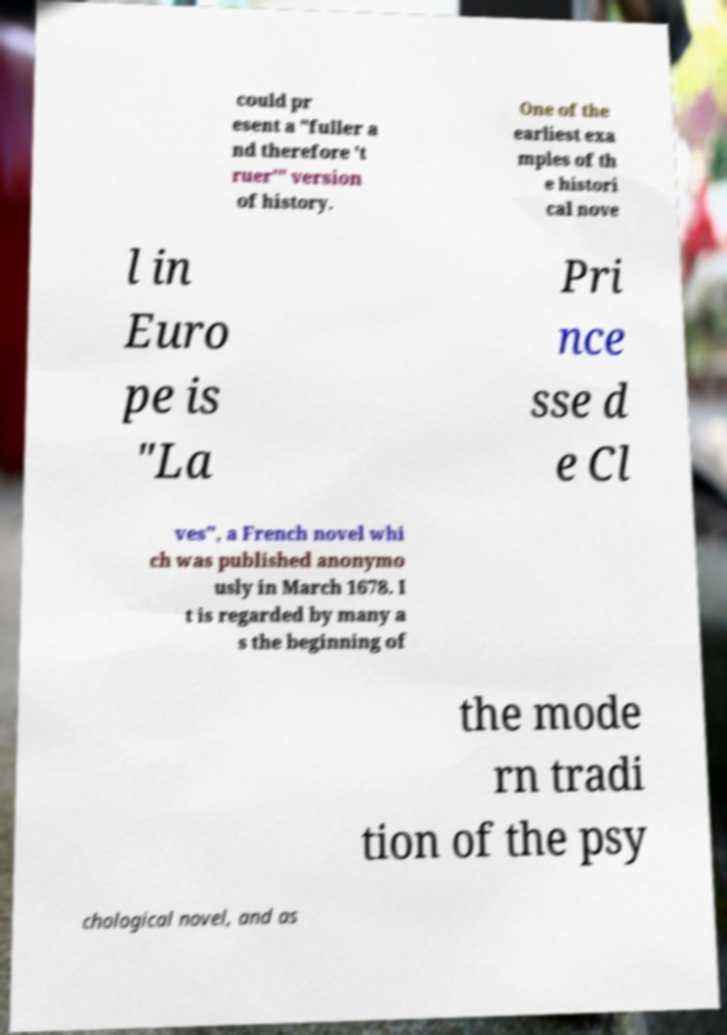I need the written content from this picture converted into text. Can you do that? could pr esent a "fuller a nd therefore 't ruer'" version of history. One of the earliest exa mples of th e histori cal nove l in Euro pe is "La Pri nce sse d e Cl ves", a French novel whi ch was published anonymo usly in March 1678. I t is regarded by many a s the beginning of the mode rn tradi tion of the psy chological novel, and as 